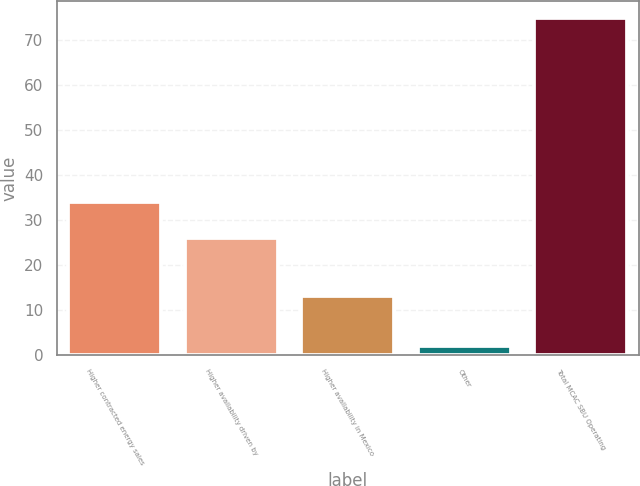Convert chart. <chart><loc_0><loc_0><loc_500><loc_500><bar_chart><fcel>Higher contracted energy sales<fcel>Higher availability driven by<fcel>Higher availability in Mexico<fcel>Other<fcel>Total MCAC SBU Operating<nl><fcel>34<fcel>26<fcel>13<fcel>2<fcel>75<nl></chart> 